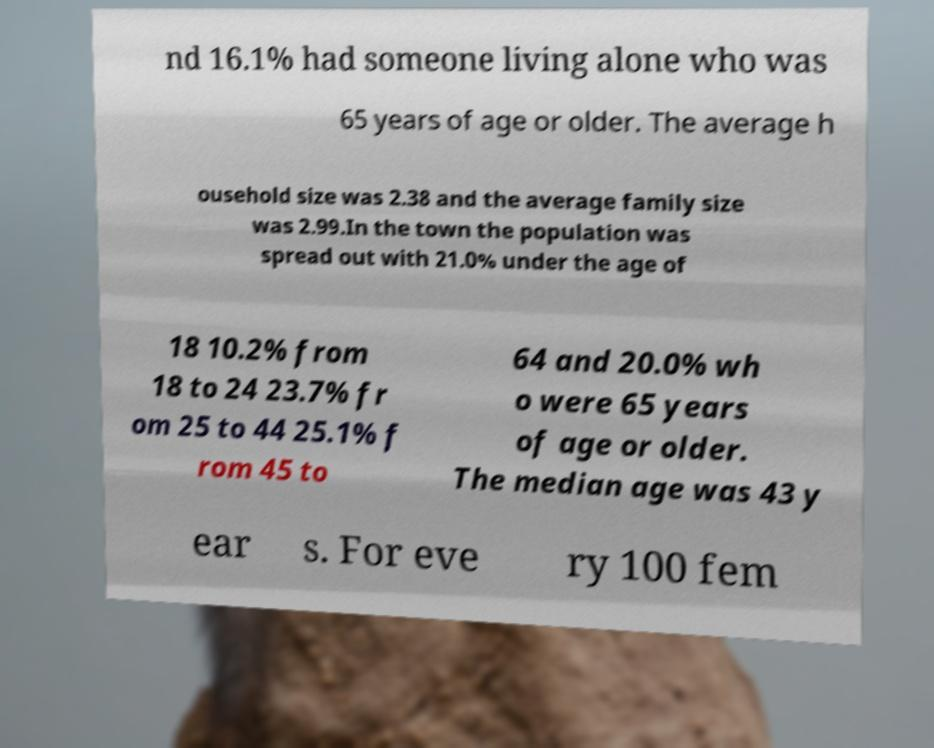I need the written content from this picture converted into text. Can you do that? nd 16.1% had someone living alone who was 65 years of age or older. The average h ousehold size was 2.38 and the average family size was 2.99.In the town the population was spread out with 21.0% under the age of 18 10.2% from 18 to 24 23.7% fr om 25 to 44 25.1% f rom 45 to 64 and 20.0% wh o were 65 years of age or older. The median age was 43 y ear s. For eve ry 100 fem 